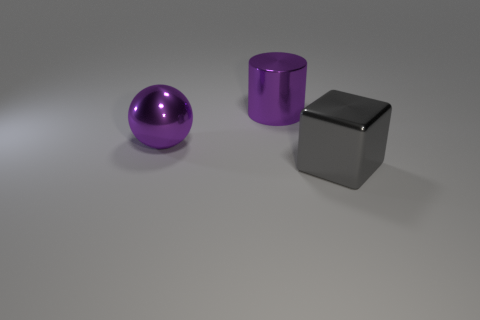Subtract all brown balls. Subtract all blue cylinders. How many balls are left? 1 Add 1 large gray things. How many objects exist? 4 Subtract all cylinders. How many objects are left? 2 Subtract 1 purple spheres. How many objects are left? 2 Subtract all small blue rubber balls. Subtract all purple metallic balls. How many objects are left? 2 Add 1 big gray metallic things. How many big gray metallic things are left? 2 Add 3 big purple metal spheres. How many big purple metal spheres exist? 4 